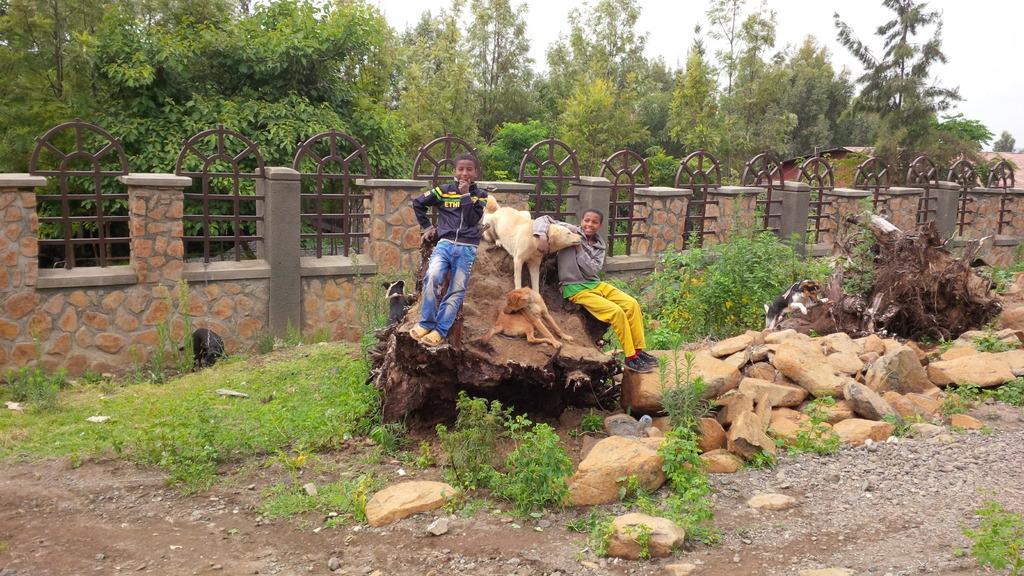Please provide a concise description of this image. In the center of the picture there are two kids and a dog on the trunk of a tree. On the right there are plants, stones, a dog a trunk. On the left there are plants and grass. In the center of the picture there is a wall, behind the wall trees, sky is cloudy. 